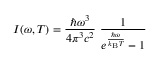Convert formula to latex. <formula><loc_0><loc_0><loc_500><loc_500>I ( \omega , T ) = { \frac { \hbar { \omega } ^ { 3 } } { 4 \pi ^ { 3 } c ^ { 2 } } } { \frac { 1 } { e ^ { \frac { \hbar { \omega } } { k _ { B } T } } - 1 } }</formula> 